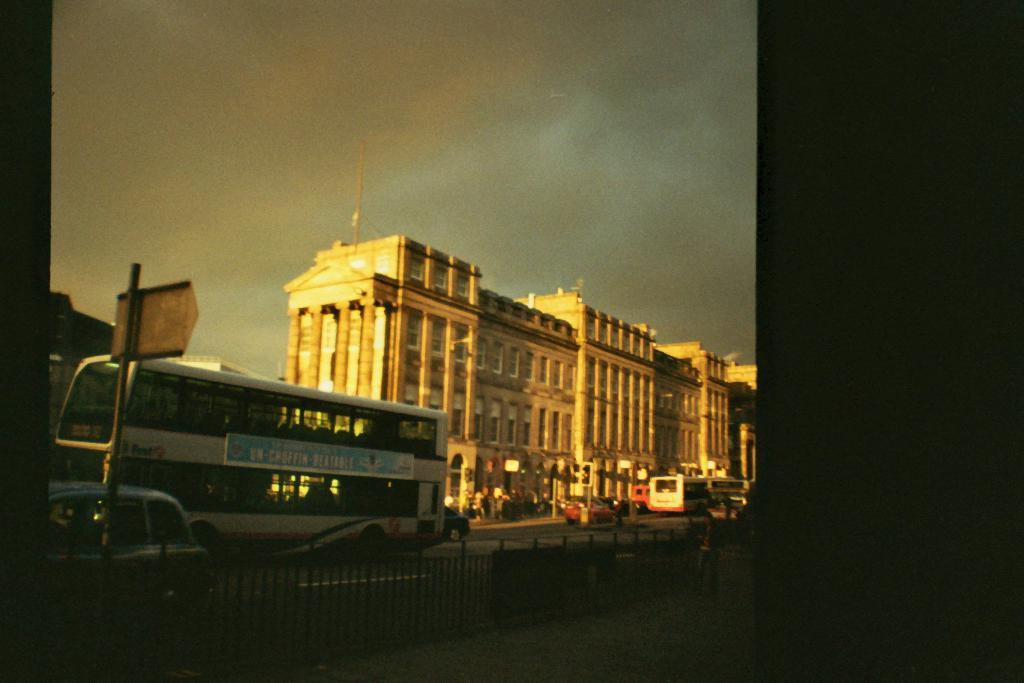What type of structure is visible in the image? There is a building in the image. What is happening in front of the building? There are moving vehicles on the road in front of the building. Can you describe any specific features of the building? There is a railing visible in the image. What can be seen in the background of the image? The sky is visible in the background of the image. What color is the ink used to write on the building in the image? There is no ink or writing present on the building in the image. What type of need is being met by the vehicles in the image? The image does not provide information about the needs of the vehicles or their occupants. 